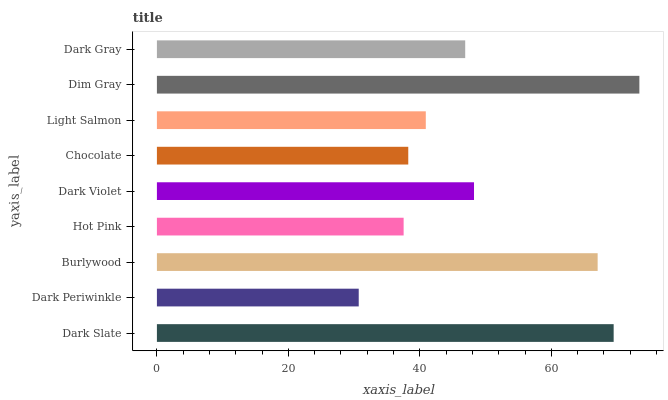Is Dark Periwinkle the minimum?
Answer yes or no. Yes. Is Dim Gray the maximum?
Answer yes or no. Yes. Is Burlywood the minimum?
Answer yes or no. No. Is Burlywood the maximum?
Answer yes or no. No. Is Burlywood greater than Dark Periwinkle?
Answer yes or no. Yes. Is Dark Periwinkle less than Burlywood?
Answer yes or no. Yes. Is Dark Periwinkle greater than Burlywood?
Answer yes or no. No. Is Burlywood less than Dark Periwinkle?
Answer yes or no. No. Is Dark Gray the high median?
Answer yes or no. Yes. Is Dark Gray the low median?
Answer yes or no. Yes. Is Dark Slate the high median?
Answer yes or no. No. Is Chocolate the low median?
Answer yes or no. No. 